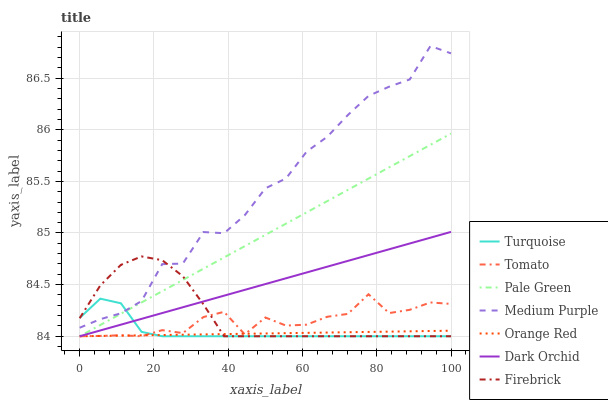Does Orange Red have the minimum area under the curve?
Answer yes or no. Yes. Does Medium Purple have the maximum area under the curve?
Answer yes or no. Yes. Does Turquoise have the minimum area under the curve?
Answer yes or no. No. Does Turquoise have the maximum area under the curve?
Answer yes or no. No. Is Orange Red the smoothest?
Answer yes or no. Yes. Is Medium Purple the roughest?
Answer yes or no. Yes. Is Turquoise the smoothest?
Answer yes or no. No. Is Turquoise the roughest?
Answer yes or no. No. Does Tomato have the lowest value?
Answer yes or no. Yes. Does Medium Purple have the lowest value?
Answer yes or no. No. Does Medium Purple have the highest value?
Answer yes or no. Yes. Does Turquoise have the highest value?
Answer yes or no. No. Is Dark Orchid less than Medium Purple?
Answer yes or no. Yes. Is Medium Purple greater than Pale Green?
Answer yes or no. Yes. Does Pale Green intersect Firebrick?
Answer yes or no. Yes. Is Pale Green less than Firebrick?
Answer yes or no. No. Is Pale Green greater than Firebrick?
Answer yes or no. No. Does Dark Orchid intersect Medium Purple?
Answer yes or no. No. 